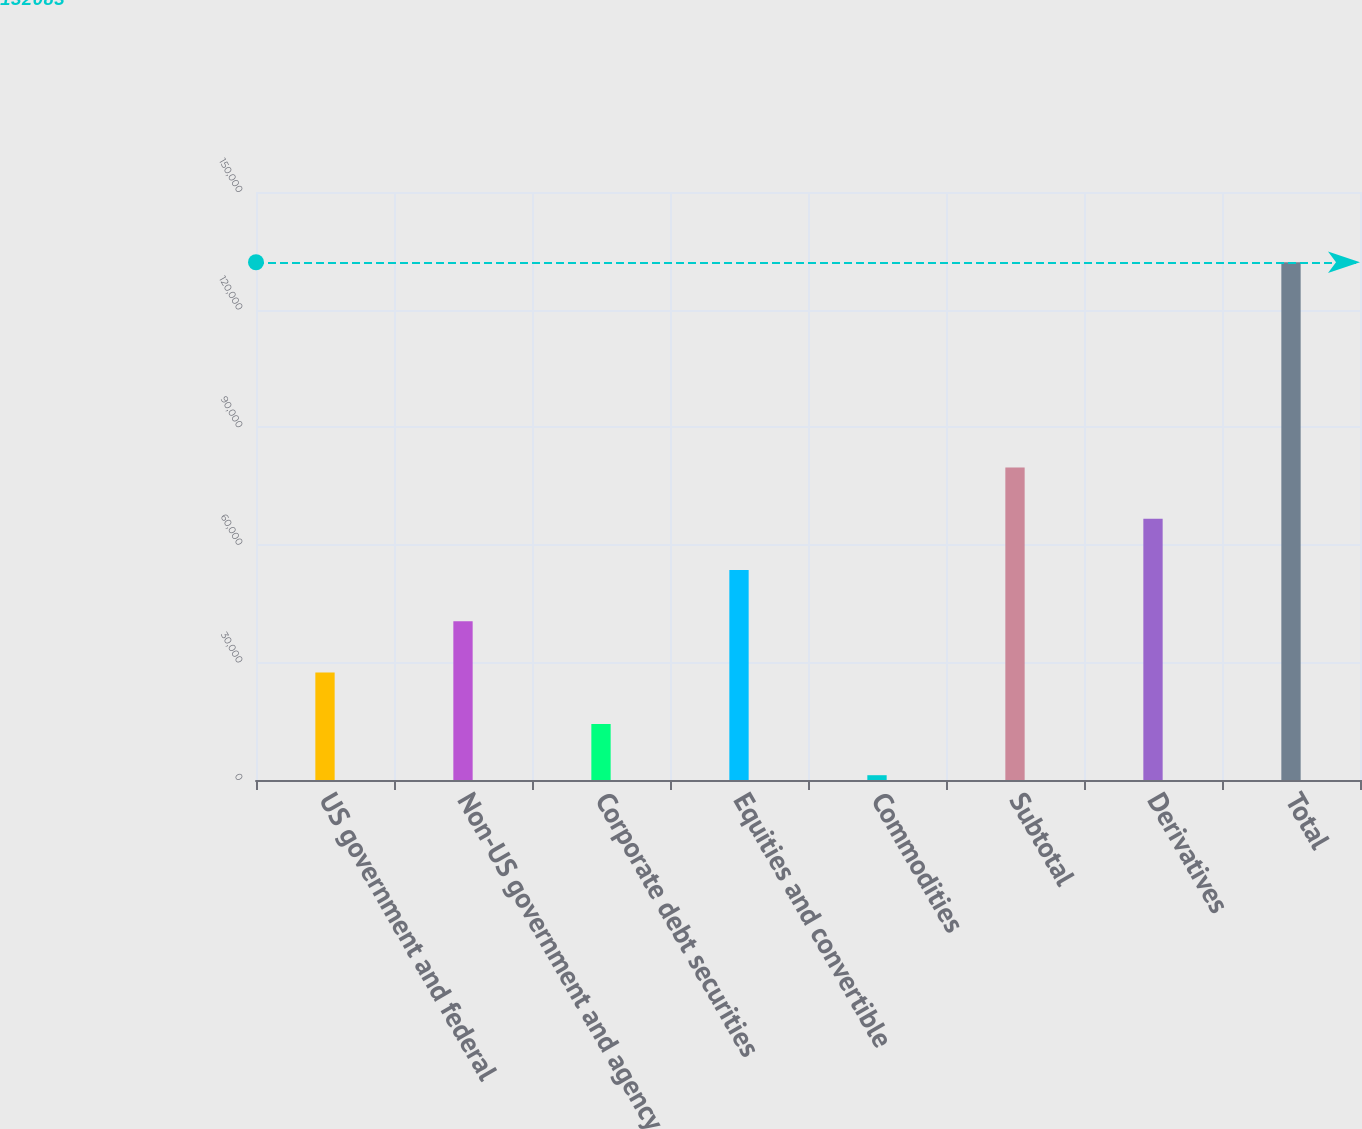<chart> <loc_0><loc_0><loc_500><loc_500><bar_chart><fcel>US government and federal<fcel>Non-US government and agency<fcel>Corporate debt securities<fcel>Equities and convertible<fcel>Commodities<fcel>Subtotal<fcel>Derivatives<fcel>Total<nl><fcel>27395.8<fcel>40481.7<fcel>14309.9<fcel>53567.6<fcel>1224<fcel>79739.4<fcel>66653.5<fcel>132083<nl></chart> 